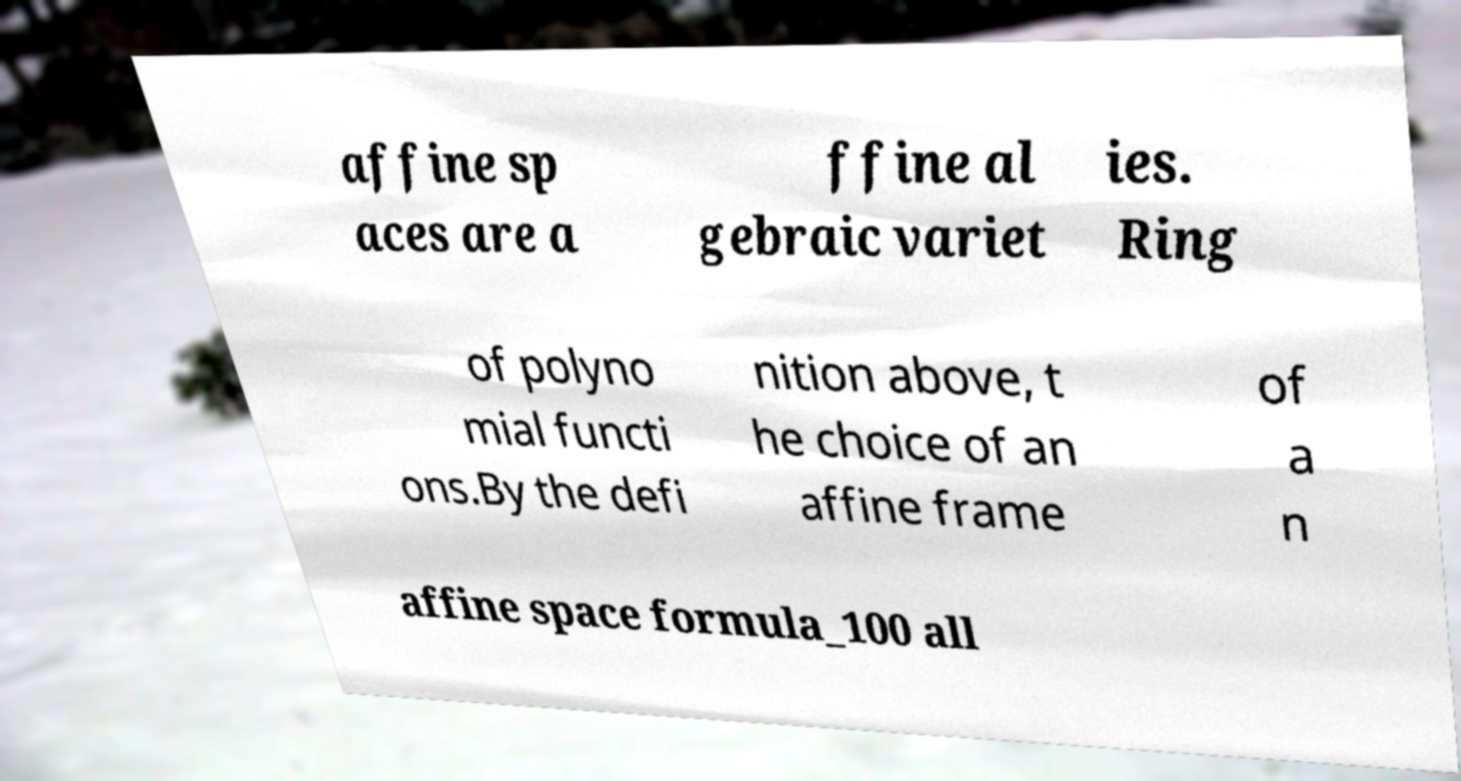Can you read and provide the text displayed in the image?This photo seems to have some interesting text. Can you extract and type it out for me? affine sp aces are a ffine al gebraic variet ies. Ring of polyno mial functi ons.By the defi nition above, t he choice of an affine frame of a n affine space formula_100 all 